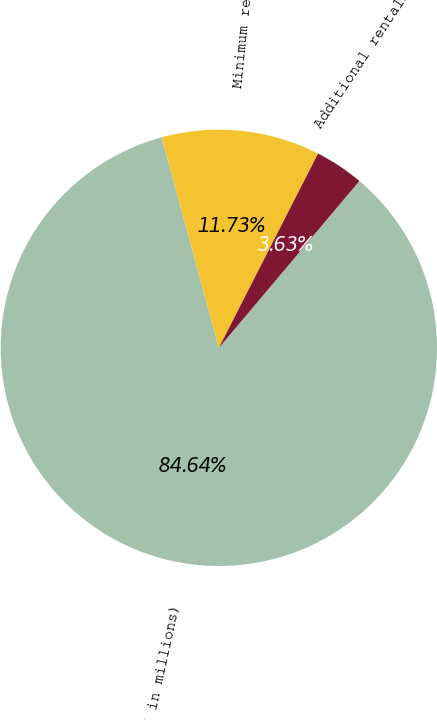Convert chart to OTSL. <chart><loc_0><loc_0><loc_500><loc_500><pie_chart><fcel>( in millions)<fcel>Minimum rentals<fcel>Additional rentals<nl><fcel>84.64%<fcel>11.73%<fcel>3.63%<nl></chart> 